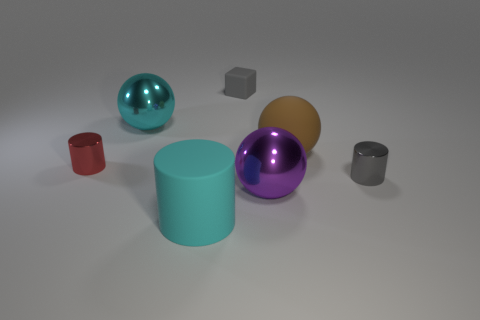Are there any other things that have the same shape as the gray rubber thing?
Provide a succinct answer. No. Is there a red object?
Offer a terse response. Yes. How many cylinders are the same color as the small block?
Your answer should be very brief. 1. There is a big object that is the same color as the large cylinder; what is it made of?
Your answer should be very brief. Metal. What size is the shiny cylinder to the left of the gray thing in front of the tiny gray rubber block?
Give a very brief answer. Small. Is there a red cylinder that has the same material as the small gray cylinder?
Offer a very short reply. Yes. There is a cyan cylinder that is the same size as the purple thing; what material is it?
Offer a terse response. Rubber. There is a big metal ball that is in front of the cyan sphere; is it the same color as the big ball behind the big rubber sphere?
Keep it short and to the point. No. There is a big ball that is in front of the small red cylinder; are there any cyan balls on the right side of it?
Provide a short and direct response. No. Does the small metal object right of the brown ball have the same shape as the matte thing that is left of the block?
Offer a very short reply. Yes. 